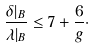<formula> <loc_0><loc_0><loc_500><loc_500>\frac { \delta | _ { B } } { \lambda | _ { B } } \leq 7 + \frac { 6 } { g } \cdot</formula> 